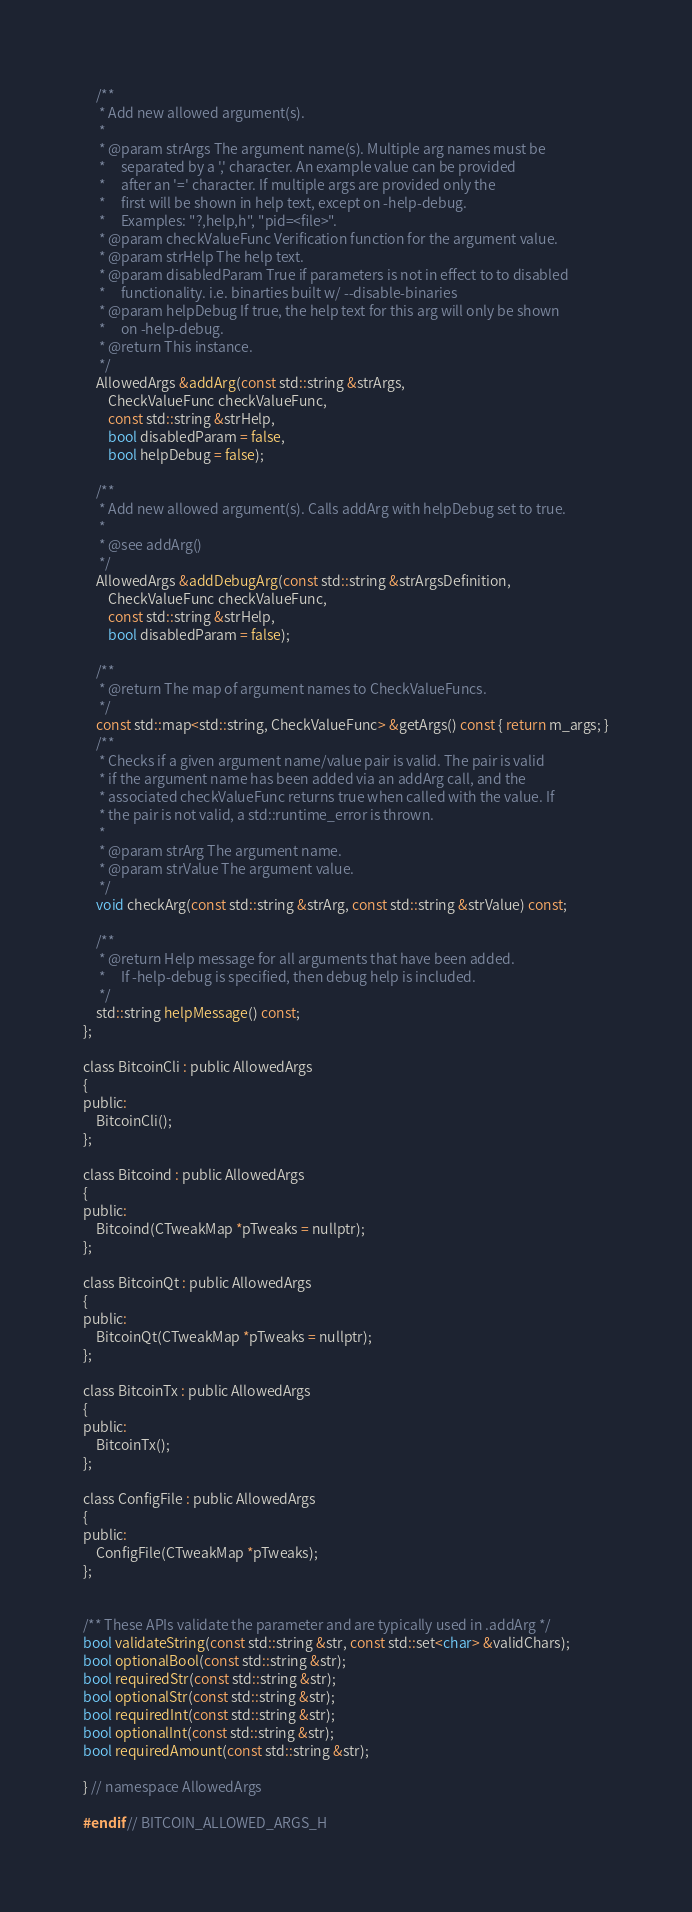Convert code to text. <code><loc_0><loc_0><loc_500><loc_500><_C_>
    /**
     * Add new allowed argument(s).
     *
     * @param strArgs The argument name(s). Multiple arg names must be
     *     separated by a ',' character. An example value can be provided
     *     after an '=' character. If multiple args are provided only the
     *     first will be shown in help text, except on -help-debug.
     *     Examples: "?,help,h", "pid=<file>".
     * @param checkValueFunc Verification function for the argument value.
     * @param strHelp The help text.
     * @param disabledParam True if parameters is not in effect to to disabled
     *     functionality. i.e. binarties built w/ --disable-binaries
     * @param helpDebug If true, the help text for this arg will only be shown
     *     on -help-debug.
     * @return This instance.
     */
    AllowedArgs &addArg(const std::string &strArgs,
        CheckValueFunc checkValueFunc,
        const std::string &strHelp,
        bool disabledParam = false,
        bool helpDebug = false);

    /**
     * Add new allowed argument(s). Calls addArg with helpDebug set to true.
     *
     * @see addArg()
     */
    AllowedArgs &addDebugArg(const std::string &strArgsDefinition,
        CheckValueFunc checkValueFunc,
        const std::string &strHelp,
        bool disabledParam = false);

    /**
     * @return The map of argument names to CheckValueFuncs.
     */
    const std::map<std::string, CheckValueFunc> &getArgs() const { return m_args; }
    /**
     * Checks if a given argument name/value pair is valid. The pair is valid
     * if the argument name has been added via an addArg call, and the
     * associated checkValueFunc returns true when called with the value. If
     * the pair is not valid, a std::runtime_error is thrown.
     *
     * @param strArg The argument name.
     * @param strValue The argument value.
     */
    void checkArg(const std::string &strArg, const std::string &strValue) const;

    /**
     * @return Help message for all arguments that have been added.
     *     If -help-debug is specified, then debug help is included.
     */
    std::string helpMessage() const;
};

class BitcoinCli : public AllowedArgs
{
public:
    BitcoinCli();
};

class Bitcoind : public AllowedArgs
{
public:
    Bitcoind(CTweakMap *pTweaks = nullptr);
};

class BitcoinQt : public AllowedArgs
{
public:
    BitcoinQt(CTweakMap *pTweaks = nullptr);
};

class BitcoinTx : public AllowedArgs
{
public:
    BitcoinTx();
};

class ConfigFile : public AllowedArgs
{
public:
    ConfigFile(CTweakMap *pTweaks);
};


/** These APIs validate the parameter and are typically used in .addArg */
bool validateString(const std::string &str, const std::set<char> &validChars);
bool optionalBool(const std::string &str);
bool requiredStr(const std::string &str);
bool optionalStr(const std::string &str);
bool requiredInt(const std::string &str);
bool optionalInt(const std::string &str);
bool requiredAmount(const std::string &str);

} // namespace AllowedArgs

#endif // BITCOIN_ALLOWED_ARGS_H
</code> 